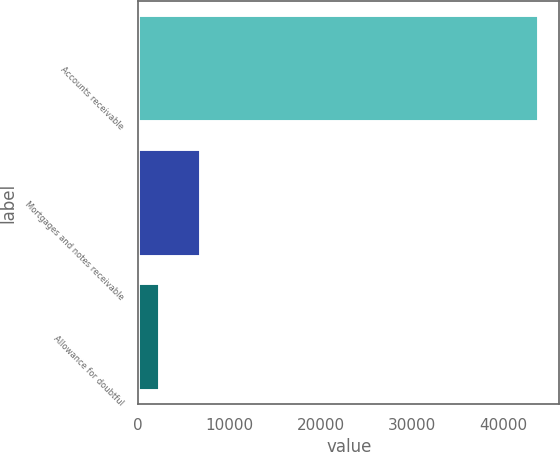Convert chart to OTSL. <chart><loc_0><loc_0><loc_500><loc_500><bar_chart><fcel>Accounts receivable<fcel>Mortgages and notes receivable<fcel>Allowance for doubtful<nl><fcel>43931<fcel>6912<fcel>2411<nl></chart> 